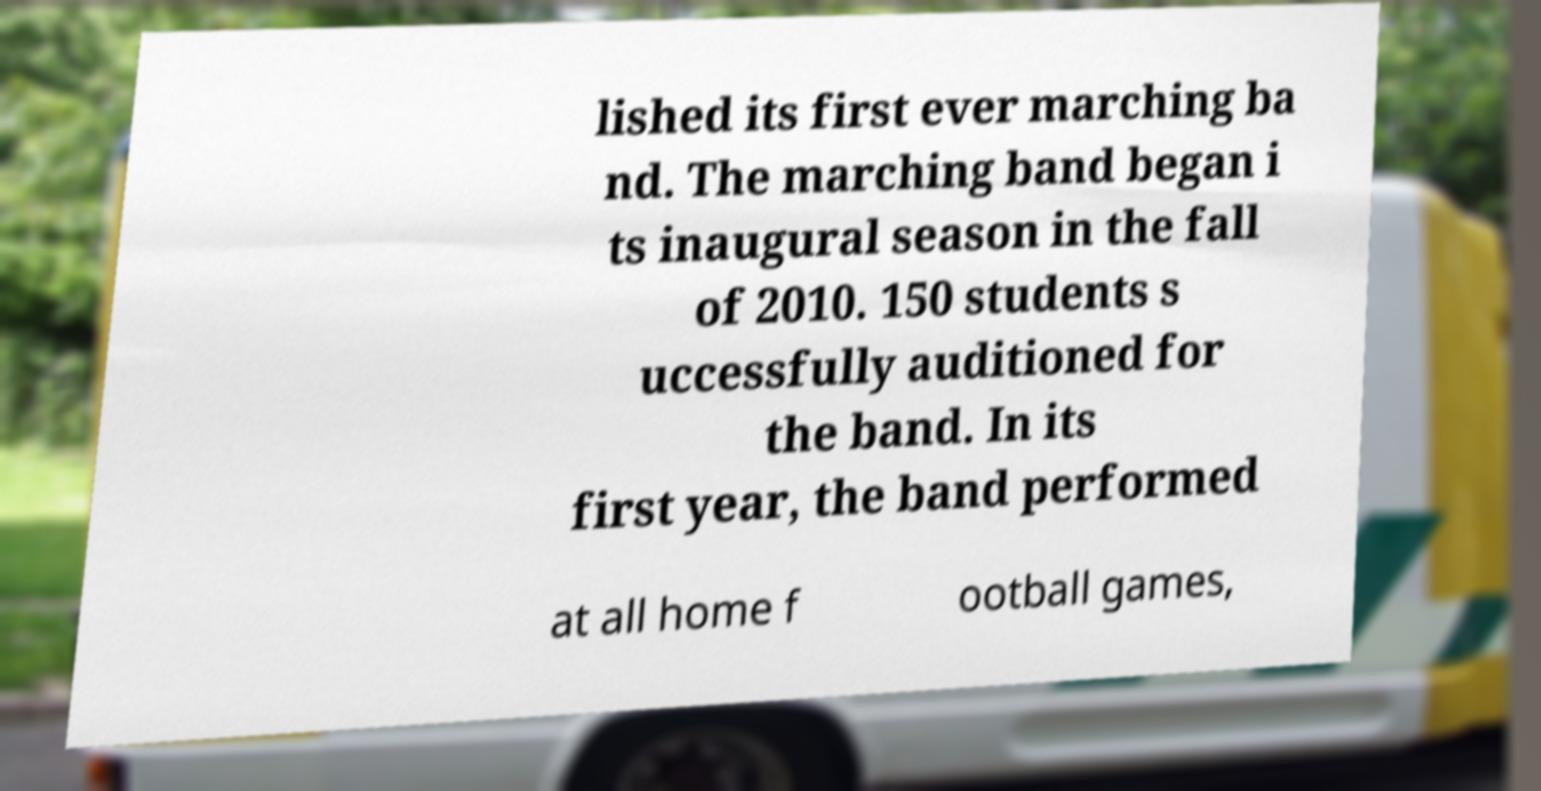There's text embedded in this image that I need extracted. Can you transcribe it verbatim? lished its first ever marching ba nd. The marching band began i ts inaugural season in the fall of 2010. 150 students s uccessfully auditioned for the band. In its first year, the band performed at all home f ootball games, 